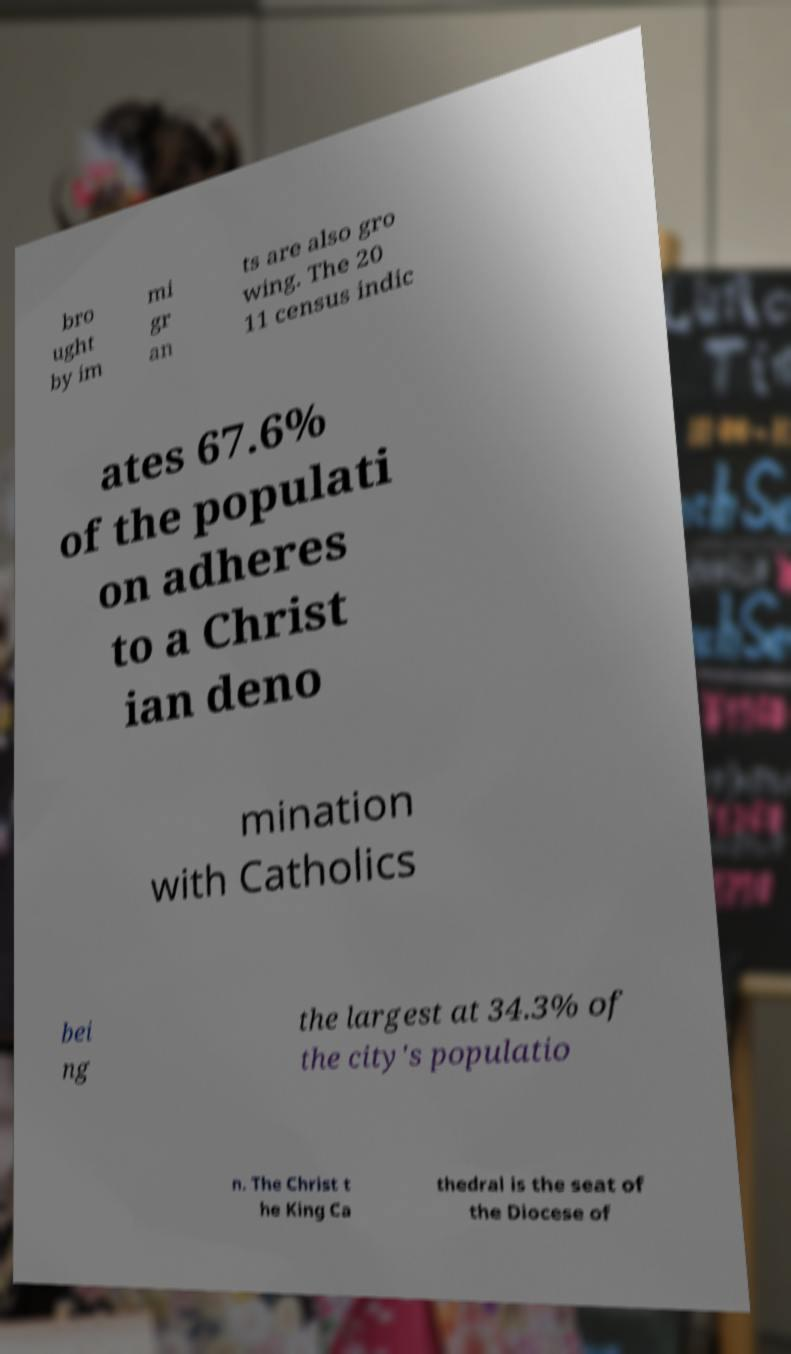Could you extract and type out the text from this image? bro ught by im mi gr an ts are also gro wing. The 20 11 census indic ates 67.6% of the populati on adheres to a Christ ian deno mination with Catholics bei ng the largest at 34.3% of the city's populatio n. The Christ t he King Ca thedral is the seat of the Diocese of 